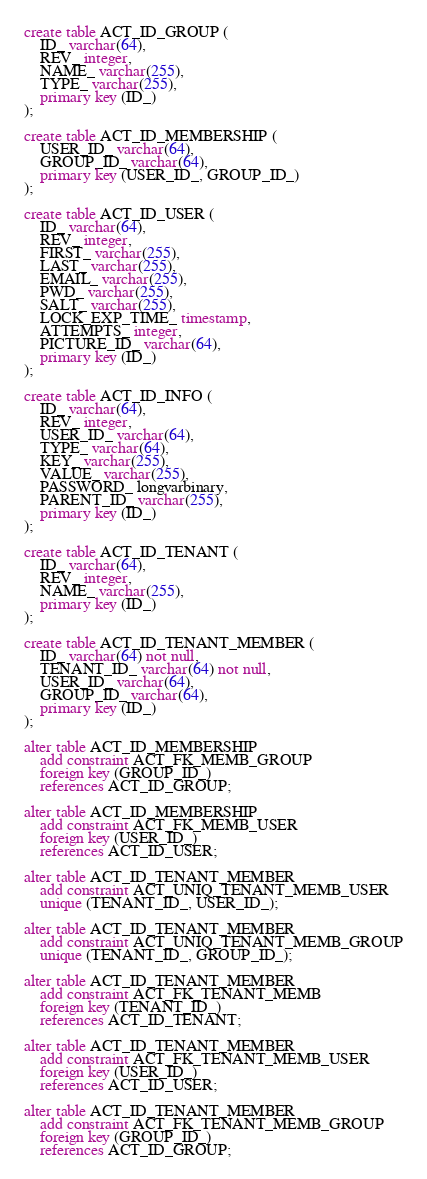<code> <loc_0><loc_0><loc_500><loc_500><_SQL_>create table ACT_ID_GROUP (
    ID_ varchar(64),
    REV_ integer,
    NAME_ varchar(255),
    TYPE_ varchar(255),
    primary key (ID_)
);

create table ACT_ID_MEMBERSHIP (
    USER_ID_ varchar(64),
    GROUP_ID_ varchar(64),
    primary key (USER_ID_, GROUP_ID_)
);

create table ACT_ID_USER (
    ID_ varchar(64),
    REV_ integer,
    FIRST_ varchar(255),
    LAST_ varchar(255),
    EMAIL_ varchar(255),
    PWD_ varchar(255),
    SALT_ varchar(255),
    LOCK_EXP_TIME_ timestamp,
    ATTEMPTS_ integer,
    PICTURE_ID_ varchar(64),
    primary key (ID_)
);

create table ACT_ID_INFO (
    ID_ varchar(64),
    REV_ integer,
    USER_ID_ varchar(64),
    TYPE_ varchar(64),
    KEY_ varchar(255),
    VALUE_ varchar(255),
    PASSWORD_ longvarbinary,
    PARENT_ID_ varchar(255),
    primary key (ID_)
);

create table ACT_ID_TENANT (
    ID_ varchar(64),
    REV_ integer,
    NAME_ varchar(255),
    primary key (ID_)
);

create table ACT_ID_TENANT_MEMBER (
    ID_ varchar(64) not null,
    TENANT_ID_ varchar(64) not null,
    USER_ID_ varchar(64),
    GROUP_ID_ varchar(64),
    primary key (ID_)
);

alter table ACT_ID_MEMBERSHIP
    add constraint ACT_FK_MEMB_GROUP
    foreign key (GROUP_ID_)
    references ACT_ID_GROUP;

alter table ACT_ID_MEMBERSHIP
    add constraint ACT_FK_MEMB_USER
    foreign key (USER_ID_)
    references ACT_ID_USER;

alter table ACT_ID_TENANT_MEMBER
    add constraint ACT_UNIQ_TENANT_MEMB_USER
    unique (TENANT_ID_, USER_ID_);

alter table ACT_ID_TENANT_MEMBER
    add constraint ACT_UNIQ_TENANT_MEMB_GROUP
    unique (TENANT_ID_, GROUP_ID_);

alter table ACT_ID_TENANT_MEMBER
    add constraint ACT_FK_TENANT_MEMB
    foreign key (TENANT_ID_)
    references ACT_ID_TENANT;

alter table ACT_ID_TENANT_MEMBER
    add constraint ACT_FK_TENANT_MEMB_USER
    foreign key (USER_ID_)
    references ACT_ID_USER;

alter table ACT_ID_TENANT_MEMBER
    add constraint ACT_FK_TENANT_MEMB_GROUP
    foreign key (GROUP_ID_)
    references ACT_ID_GROUP;
</code> 